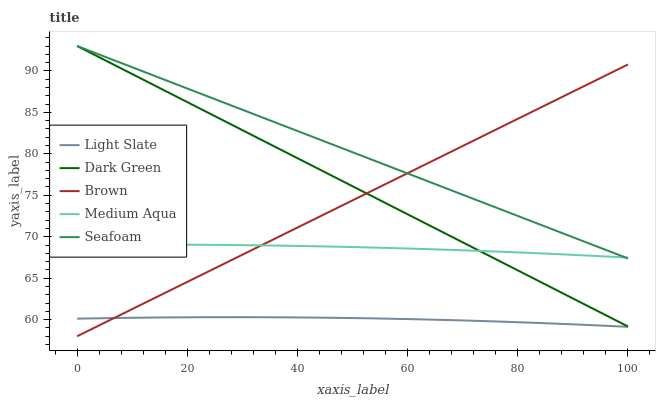Does Light Slate have the minimum area under the curve?
Answer yes or no. Yes. Does Seafoam have the maximum area under the curve?
Answer yes or no. Yes. Does Brown have the minimum area under the curve?
Answer yes or no. No. Does Brown have the maximum area under the curve?
Answer yes or no. No. Is Dark Green the smoothest?
Answer yes or no. Yes. Is Light Slate the roughest?
Answer yes or no. Yes. Is Brown the smoothest?
Answer yes or no. No. Is Brown the roughest?
Answer yes or no. No. Does Brown have the lowest value?
Answer yes or no. Yes. Does Medium Aqua have the lowest value?
Answer yes or no. No. Does Dark Green have the highest value?
Answer yes or no. Yes. Does Brown have the highest value?
Answer yes or no. No. Is Light Slate less than Medium Aqua?
Answer yes or no. Yes. Is Medium Aqua greater than Light Slate?
Answer yes or no. Yes. Does Seafoam intersect Brown?
Answer yes or no. Yes. Is Seafoam less than Brown?
Answer yes or no. No. Is Seafoam greater than Brown?
Answer yes or no. No. Does Light Slate intersect Medium Aqua?
Answer yes or no. No. 